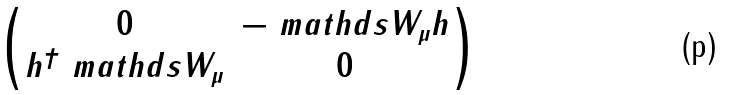Convert formula to latex. <formula><loc_0><loc_0><loc_500><loc_500>\begin{pmatrix} 0 & - \ m a t h d s { W } _ { \mu } h \\ h ^ { \dagger } \ m a t h d s { W } _ { \mu } & 0 \end{pmatrix}</formula> 